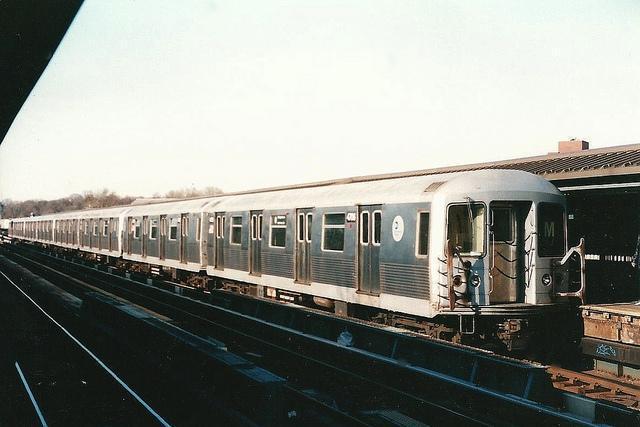How many trains are visible?
Give a very brief answer. 1. How many stacks of bowls are there?
Give a very brief answer. 0. 